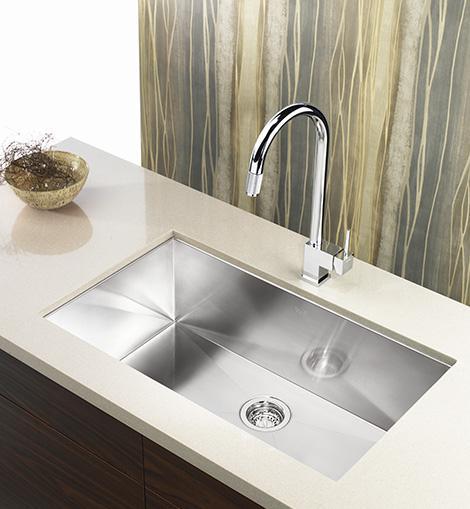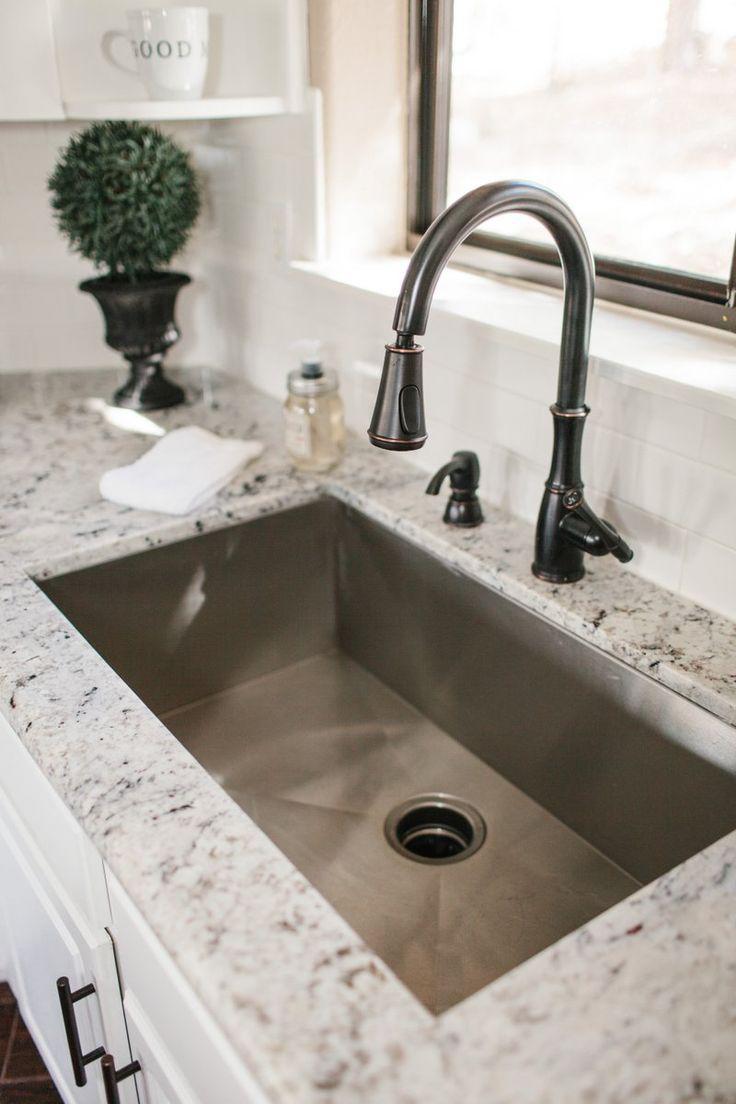The first image is the image on the left, the second image is the image on the right. For the images shown, is this caption "A large sink is surrounded by a marbled countertop." true? Answer yes or no. Yes. 